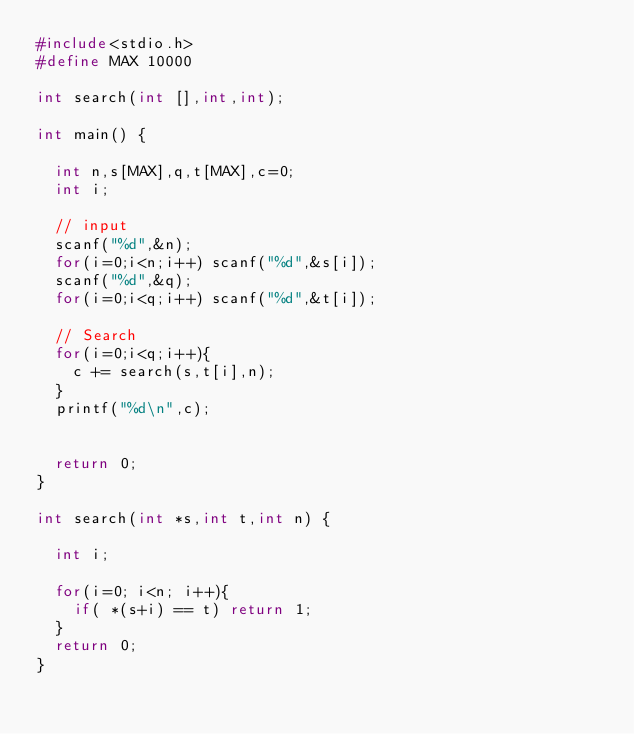<code> <loc_0><loc_0><loc_500><loc_500><_C_>#include<stdio.h>
#define MAX 10000

int search(int [],int,int);

int main() {
  
  int n,s[MAX],q,t[MAX],c=0;
  int i;
  
  // input
  scanf("%d",&n);
  for(i=0;i<n;i++) scanf("%d",&s[i]);
  scanf("%d",&q);
  for(i=0;i<q;i++) scanf("%d",&t[i]);
  
  // Search
  for(i=0;i<q;i++){
    c += search(s,t[i],n);
  }
  printf("%d\n",c);
  
  
  return 0;
}

int search(int *s,int t,int n) {
  
  int i;
  
  for(i=0; i<n; i++){ 
    if( *(s+i) == t) return 1;
  }
  return 0;
}</code> 